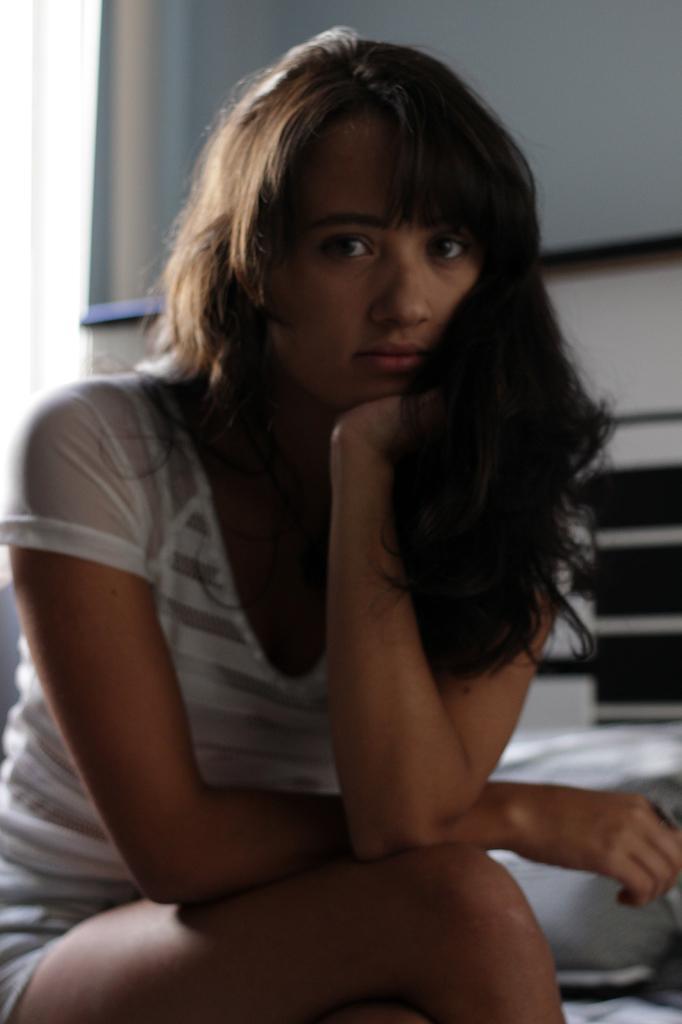In one or two sentences, can you explain what this image depicts? In this image we can see a lady. She is sitting. In the background it is blur. And there is a wall. 